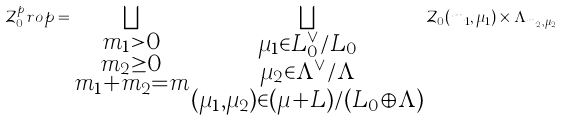<formula> <loc_0><loc_0><loc_500><loc_500>\mathcal { Z } _ { 0 } ^ { p } r o p = \bigsqcup _ { \substack { m _ { 1 } > 0 \\ m _ { 2 } \geq 0 \\ m _ { 1 } + m _ { 2 } = m } } \bigsqcup _ { \substack { \mu _ { 1 } \in L _ { 0 } ^ { \vee } / L _ { 0 } \\ \mu _ { 2 } \in \Lambda ^ { \vee } / \Lambda \\ ( \mu _ { 1 } , \mu _ { 2 } ) \in ( \mu + L ) / ( L _ { 0 } \oplus \Lambda ) } } \mathcal { Z } _ { 0 } ( m _ { 1 } , \mu _ { 1 } ) \times \Lambda _ { m _ { 2 } , \mu _ { 2 } }</formula> 